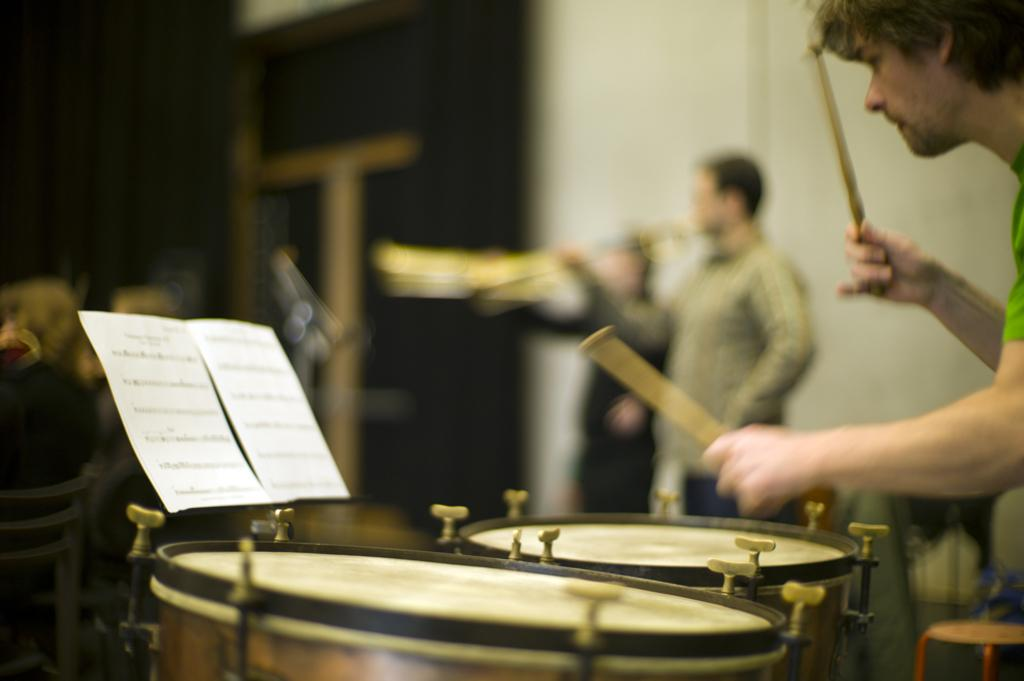What is the color of the wall in the image? The wall in the image is white. How many people are present in the image? There are three people in the image. What activity is one of the people engaged in? One of the people is playing drums. Can you describe the taste of the fang in the image? There is no fang present in the image, so it is not possible to describe its taste. 